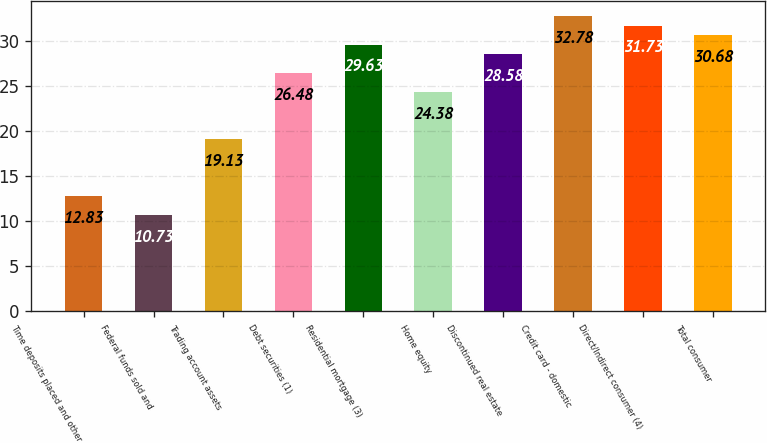Convert chart to OTSL. <chart><loc_0><loc_0><loc_500><loc_500><bar_chart><fcel>Time deposits placed and other<fcel>Federal funds sold and<fcel>Trading account assets<fcel>Debt securities (1)<fcel>Residential mortgage (3)<fcel>Home equity<fcel>Discontinued real estate<fcel>Credit card - domestic<fcel>Direct/Indirect consumer (4)<fcel>Total consumer<nl><fcel>12.83<fcel>10.73<fcel>19.13<fcel>26.48<fcel>29.63<fcel>24.38<fcel>28.58<fcel>32.78<fcel>31.73<fcel>30.68<nl></chart> 